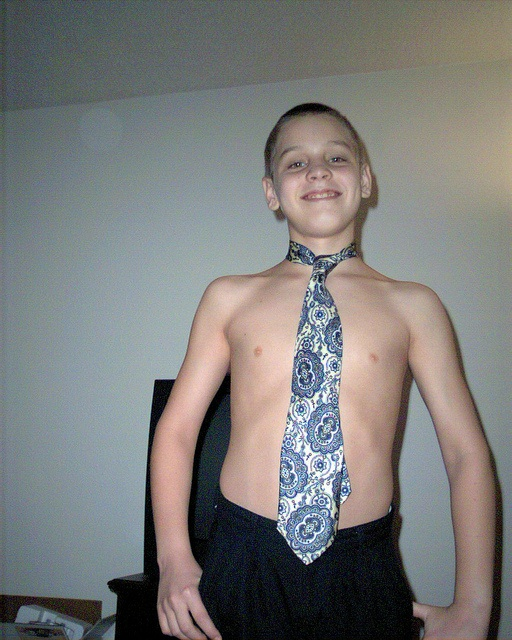Describe the objects in this image and their specific colors. I can see people in black, darkgray, tan, and gray tones, tie in black, ivory, gray, and darkgray tones, and tv in black and gray tones in this image. 